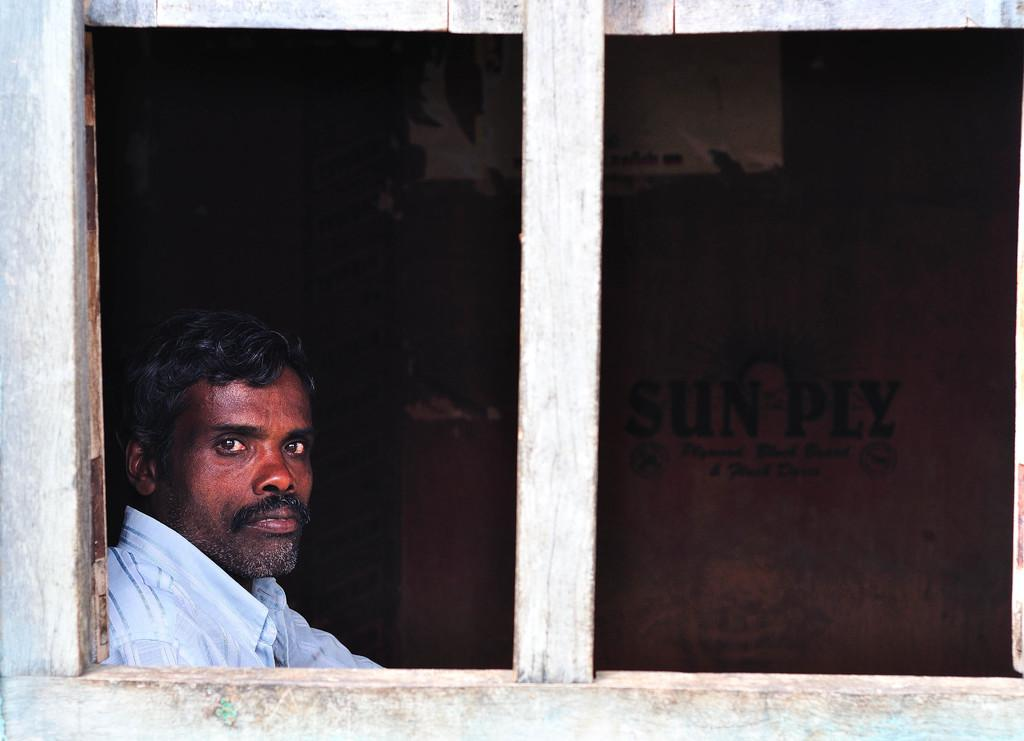Who or what is present in the image? There is a person in the image. What is the person wearing? The person is wearing a white shirt. What can be seen in front of the person? There is a window in front of the person. What is the color of the background in the image? The background of the image is brown in color. What type of bat is flying around in the image? There is no bat present in the image. What furniture can be seen in the image? The provided facts do not mention any furniture in the image. 